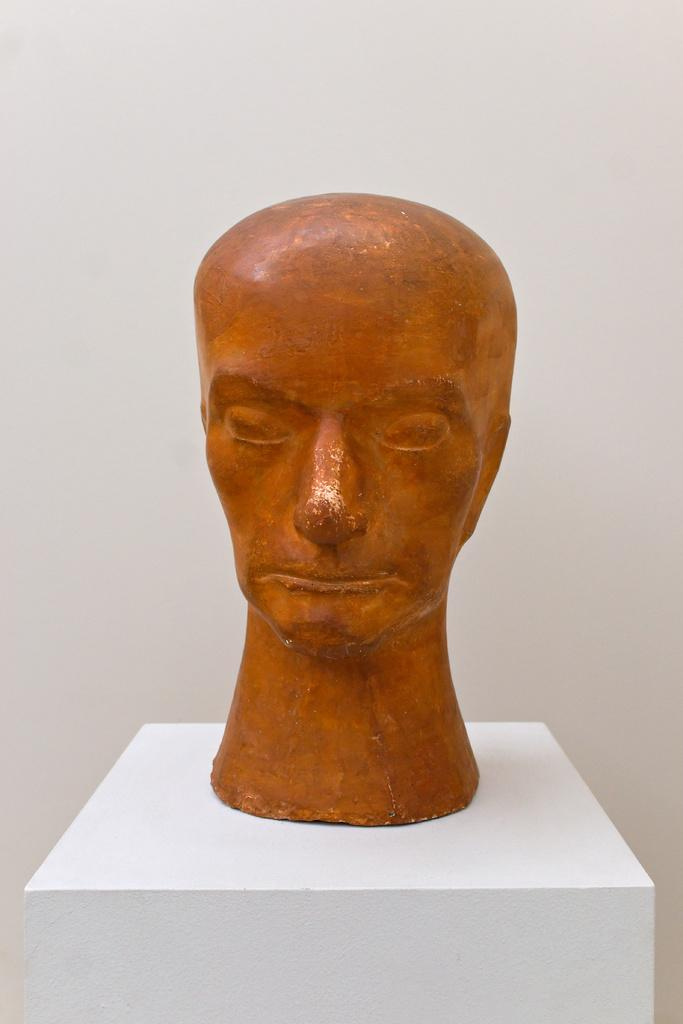What can be seen in the background of the image? There is a wall in the background of the image. What is the main subject of the image? The main subject of the image is a sculpture. How is the sculpture positioned in the image? The sculpture is placed on a pedestal. How many chickens are present in the image? There are no chickens present in the image. What type of zephyr can be seen blowing through the cave in the image? There is no cave or zephyr present in the image; it features a sculpture on a pedestal with a wall in the background. 